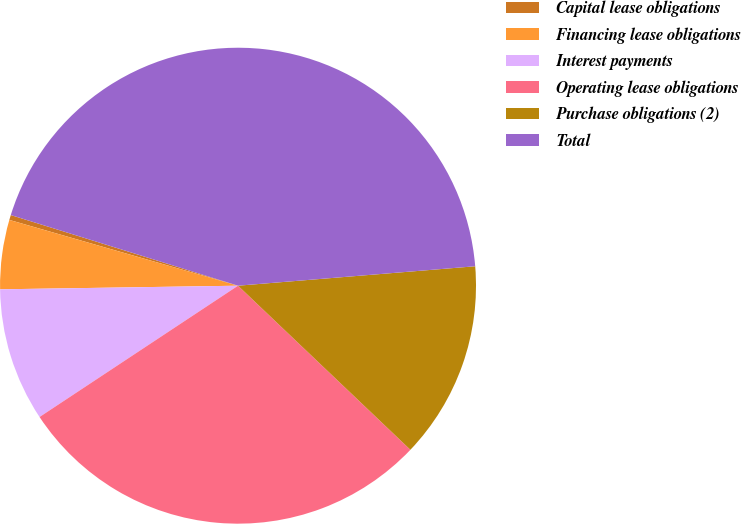Convert chart. <chart><loc_0><loc_0><loc_500><loc_500><pie_chart><fcel>Capital lease obligations<fcel>Financing lease obligations<fcel>Interest payments<fcel>Operating lease obligations<fcel>Purchase obligations (2)<fcel>Total<nl><fcel>0.34%<fcel>4.7%<fcel>9.06%<fcel>28.59%<fcel>13.41%<fcel>43.9%<nl></chart> 